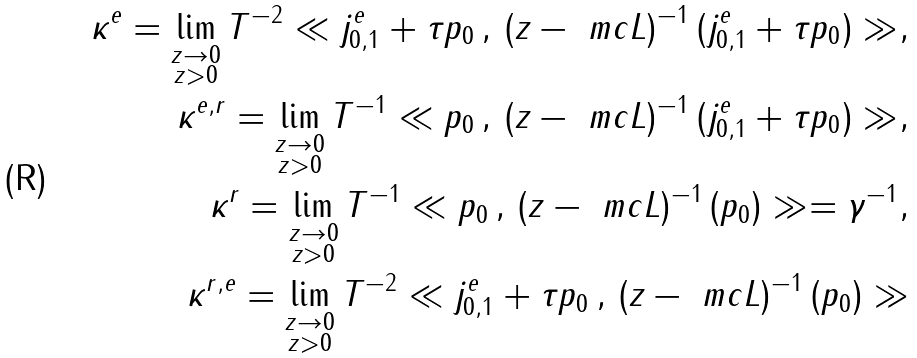Convert formula to latex. <formula><loc_0><loc_0><loc_500><loc_500>\kappa ^ { e } = \lim _ { \substack { z \to 0 \\ z > 0 } } T ^ { - 2 } \ll j ^ { e } _ { 0 , 1 } + \tau p _ { 0 } \, , \, ( z - { \ m c L } ) ^ { - 1 } \, ( j ^ { e } _ { 0 , 1 } + \tau p _ { 0 } ) \gg , \\ \kappa ^ { e , r } = \lim _ { \substack { z \to 0 \\ z > 0 } } T ^ { - 1 } \ll p _ { 0 } \, , \, ( z - { \ m c L } ) ^ { - 1 } \, ( j ^ { e } _ { 0 , 1 } + \tau p _ { 0 } ) \gg , \\ \kappa ^ { r } = \lim _ { \substack { z \to 0 \\ z > 0 } } T ^ { - 1 } \ll p _ { 0 } \, , \, ( z - { \ m c L } ) ^ { - 1 } \, ( p _ { 0 } ) \gg = \gamma ^ { - 1 } , \\ \kappa ^ { r , e } = \lim _ { \substack { z \to 0 \\ z > 0 } } T ^ { - 2 } \ll j ^ { e } _ { 0 , 1 } + \tau p _ { 0 } \, , \, ( z - { \ m c L } ) ^ { - 1 } \, ( p _ { 0 } ) \gg</formula> 